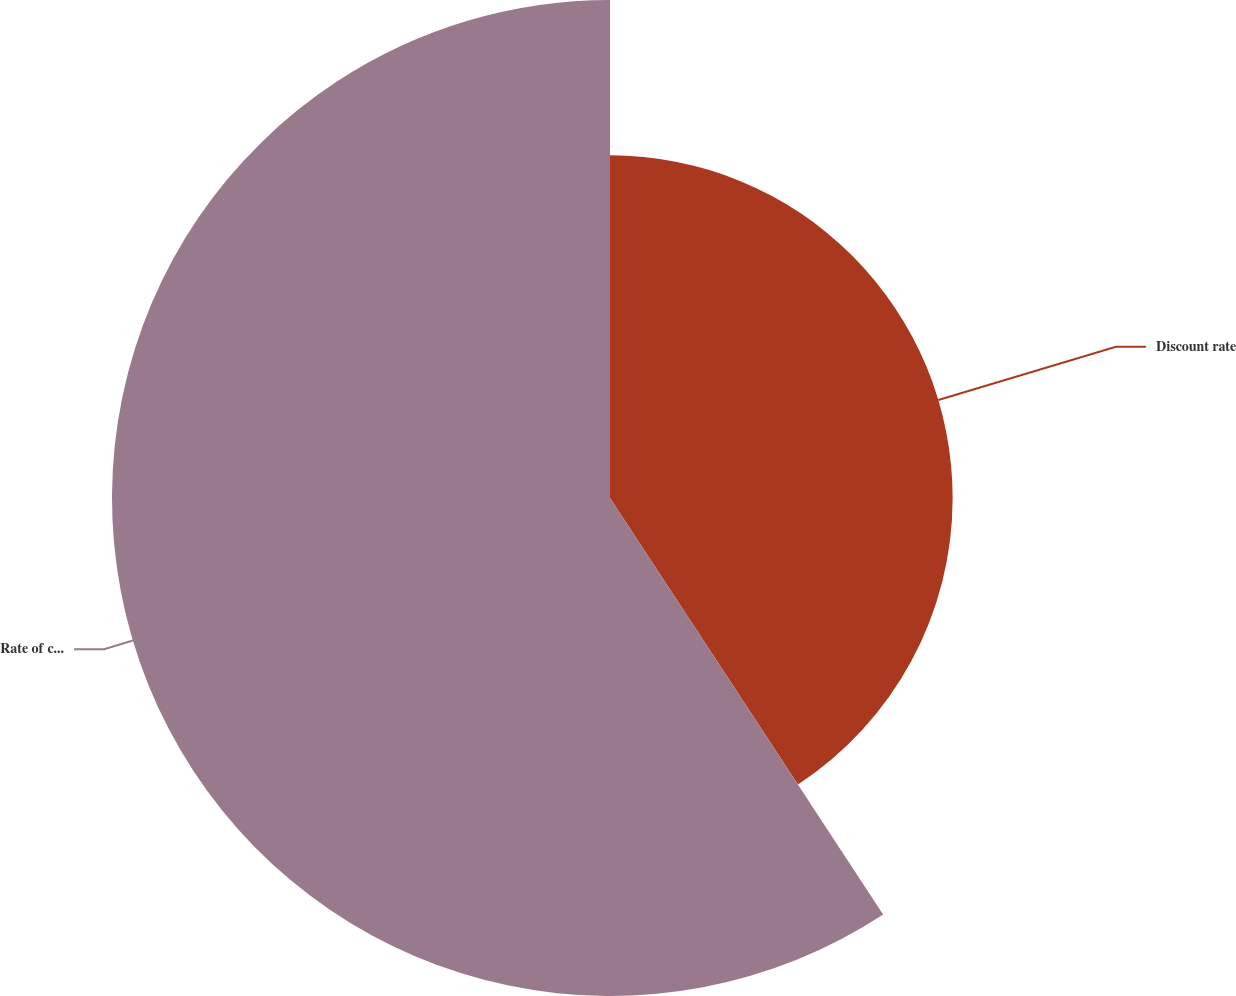<chart> <loc_0><loc_0><loc_500><loc_500><pie_chart><fcel>Discount rate<fcel>Rate of compensation increase<nl><fcel>40.76%<fcel>59.24%<nl></chart> 